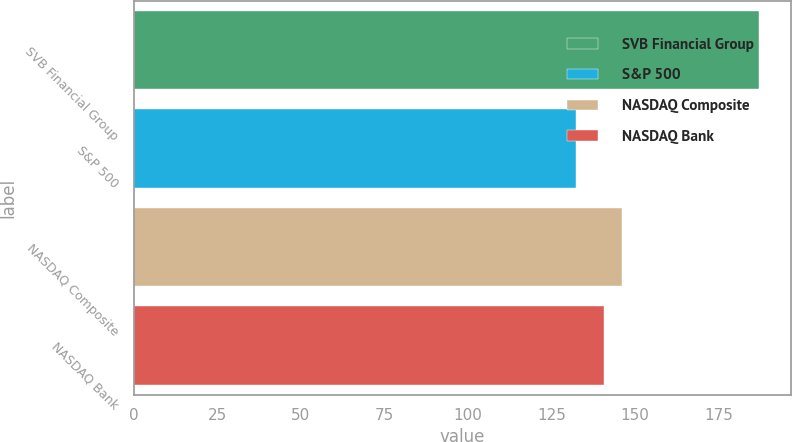<chart> <loc_0><loc_0><loc_500><loc_500><bar_chart><fcel>SVB Financial Group<fcel>S&P 500<fcel>NASDAQ Composite<fcel>NASDAQ Bank<nl><fcel>187.35<fcel>132.39<fcel>146.26<fcel>140.76<nl></chart> 